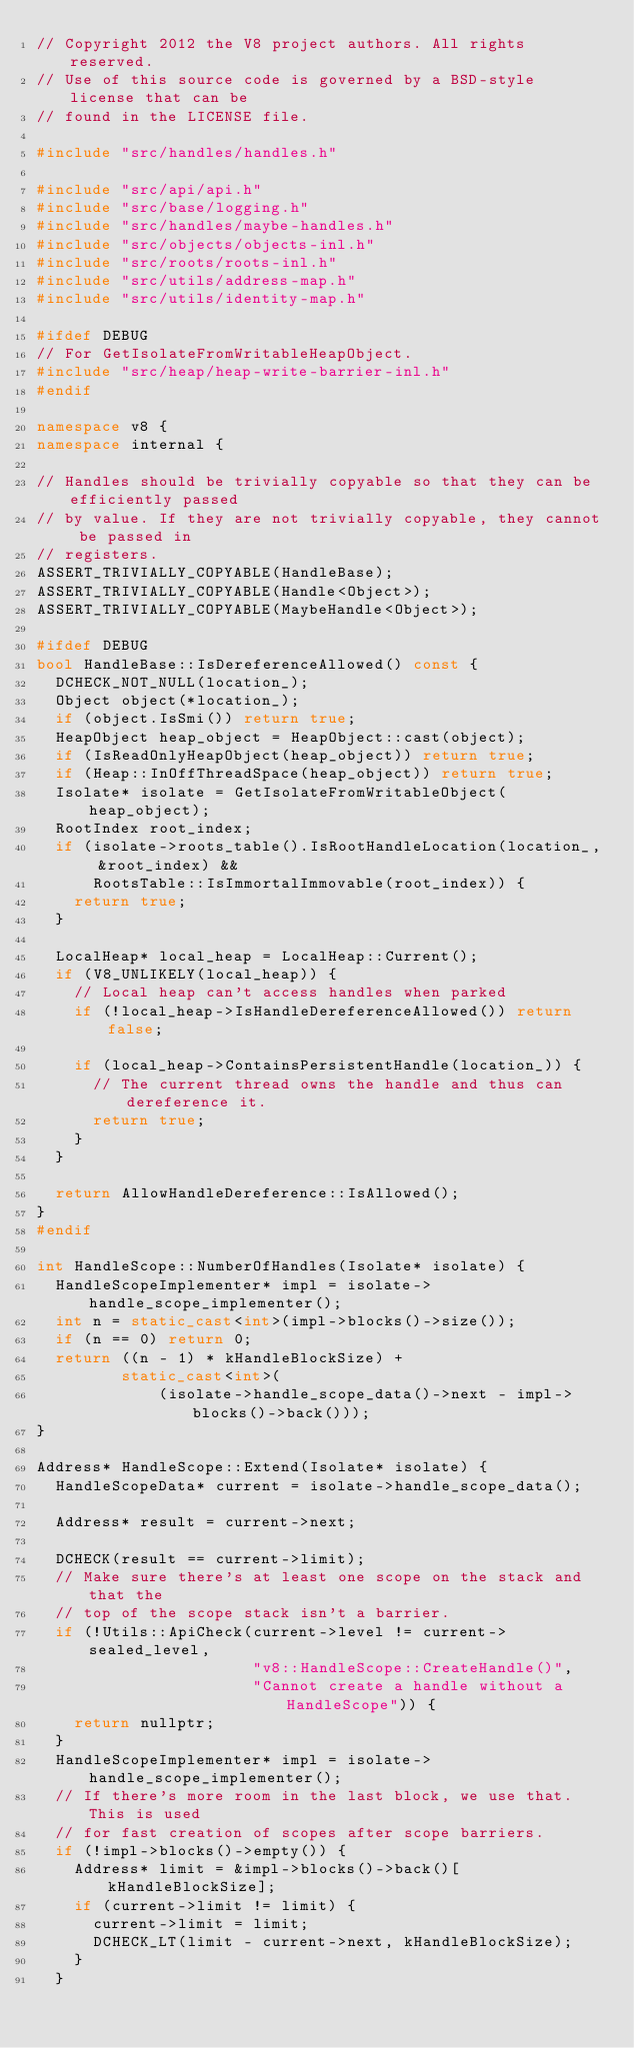Convert code to text. <code><loc_0><loc_0><loc_500><loc_500><_C++_>// Copyright 2012 the V8 project authors. All rights reserved.
// Use of this source code is governed by a BSD-style license that can be
// found in the LICENSE file.

#include "src/handles/handles.h"

#include "src/api/api.h"
#include "src/base/logging.h"
#include "src/handles/maybe-handles.h"
#include "src/objects/objects-inl.h"
#include "src/roots/roots-inl.h"
#include "src/utils/address-map.h"
#include "src/utils/identity-map.h"

#ifdef DEBUG
// For GetIsolateFromWritableHeapObject.
#include "src/heap/heap-write-barrier-inl.h"
#endif

namespace v8 {
namespace internal {

// Handles should be trivially copyable so that they can be efficiently passed
// by value. If they are not trivially copyable, they cannot be passed in
// registers.
ASSERT_TRIVIALLY_COPYABLE(HandleBase);
ASSERT_TRIVIALLY_COPYABLE(Handle<Object>);
ASSERT_TRIVIALLY_COPYABLE(MaybeHandle<Object>);

#ifdef DEBUG
bool HandleBase::IsDereferenceAllowed() const {
  DCHECK_NOT_NULL(location_);
  Object object(*location_);
  if (object.IsSmi()) return true;
  HeapObject heap_object = HeapObject::cast(object);
  if (IsReadOnlyHeapObject(heap_object)) return true;
  if (Heap::InOffThreadSpace(heap_object)) return true;
  Isolate* isolate = GetIsolateFromWritableObject(heap_object);
  RootIndex root_index;
  if (isolate->roots_table().IsRootHandleLocation(location_, &root_index) &&
      RootsTable::IsImmortalImmovable(root_index)) {
    return true;
  }

  LocalHeap* local_heap = LocalHeap::Current();
  if (V8_UNLIKELY(local_heap)) {
    // Local heap can't access handles when parked
    if (!local_heap->IsHandleDereferenceAllowed()) return false;

    if (local_heap->ContainsPersistentHandle(location_)) {
      // The current thread owns the handle and thus can dereference it.
      return true;
    }
  }

  return AllowHandleDereference::IsAllowed();
}
#endif

int HandleScope::NumberOfHandles(Isolate* isolate) {
  HandleScopeImplementer* impl = isolate->handle_scope_implementer();
  int n = static_cast<int>(impl->blocks()->size());
  if (n == 0) return 0;
  return ((n - 1) * kHandleBlockSize) +
         static_cast<int>(
             (isolate->handle_scope_data()->next - impl->blocks()->back()));
}

Address* HandleScope::Extend(Isolate* isolate) {
  HandleScopeData* current = isolate->handle_scope_data();

  Address* result = current->next;

  DCHECK(result == current->limit);
  // Make sure there's at least one scope on the stack and that the
  // top of the scope stack isn't a barrier.
  if (!Utils::ApiCheck(current->level != current->sealed_level,
                       "v8::HandleScope::CreateHandle()",
                       "Cannot create a handle without a HandleScope")) {
    return nullptr;
  }
  HandleScopeImplementer* impl = isolate->handle_scope_implementer();
  // If there's more room in the last block, we use that. This is used
  // for fast creation of scopes after scope barriers.
  if (!impl->blocks()->empty()) {
    Address* limit = &impl->blocks()->back()[kHandleBlockSize];
    if (current->limit != limit) {
      current->limit = limit;
      DCHECK_LT(limit - current->next, kHandleBlockSize);
    }
  }
</code> 